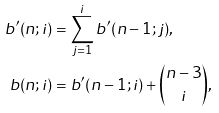<formula> <loc_0><loc_0><loc_500><loc_500>b ^ { \prime } ( n ; i ) & = \sum _ { j = 1 } ^ { i } b ^ { \prime } ( n - 1 ; j ) , \\ b ( n ; i ) & = b ^ { \prime } ( n - 1 ; i ) + \binom { n - 3 } { i } ,</formula> 